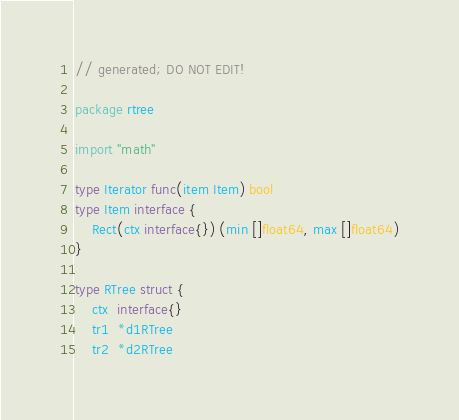Convert code to text. <code><loc_0><loc_0><loc_500><loc_500><_Go_>// generated; DO NOT EDIT!

package rtree

import "math"

type Iterator func(item Item) bool
type Item interface {
	Rect(ctx interface{}) (min []float64, max []float64)
}

type RTree struct {
	ctx  interface{}
	tr1  *d1RTree
	tr2  *d2RTree</code> 